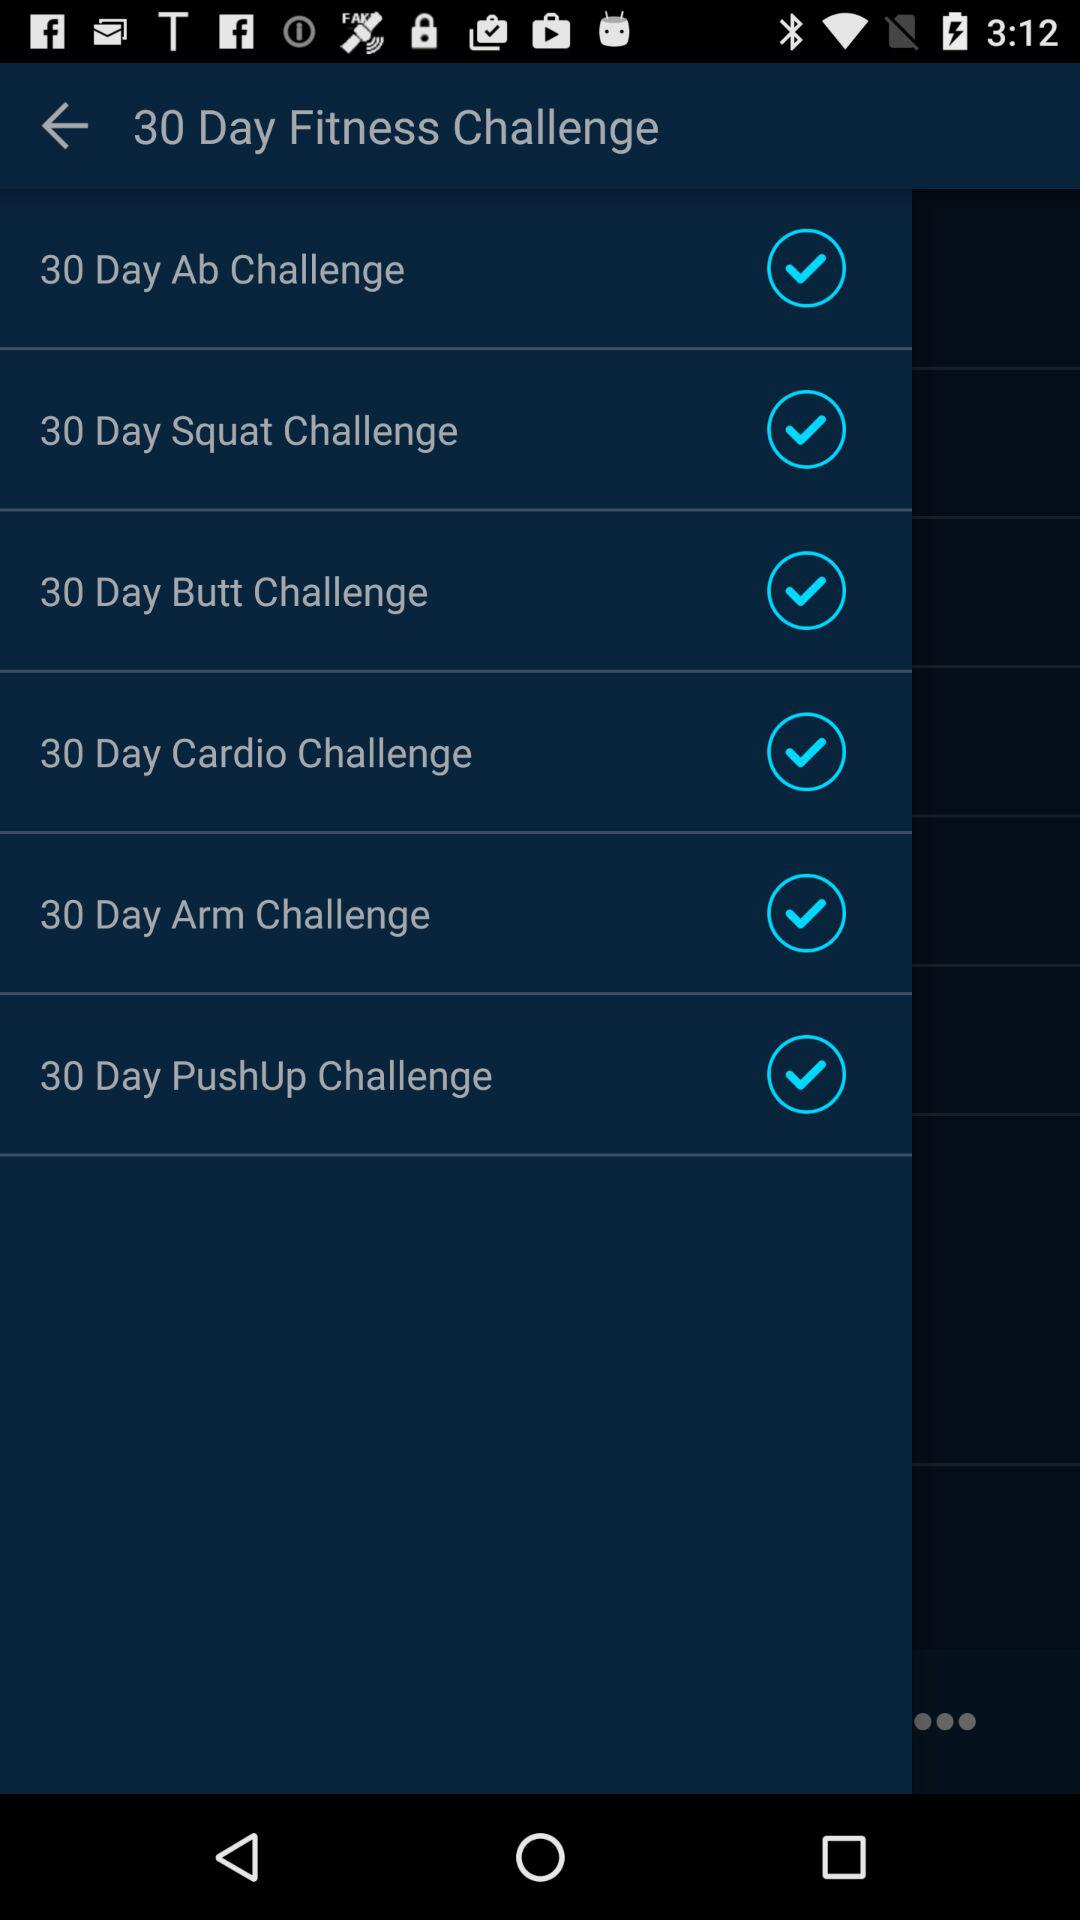What are the 30 day fitness challenges? The 30 day fitness challenges are "30 Day Ab Challenge", "30 Day Squat Challenge", "30 Day Butt Challenge", "30 Day Cardio Challenge", "30 Day Arm Challenge" and "30 Day PushUp Challenge". 